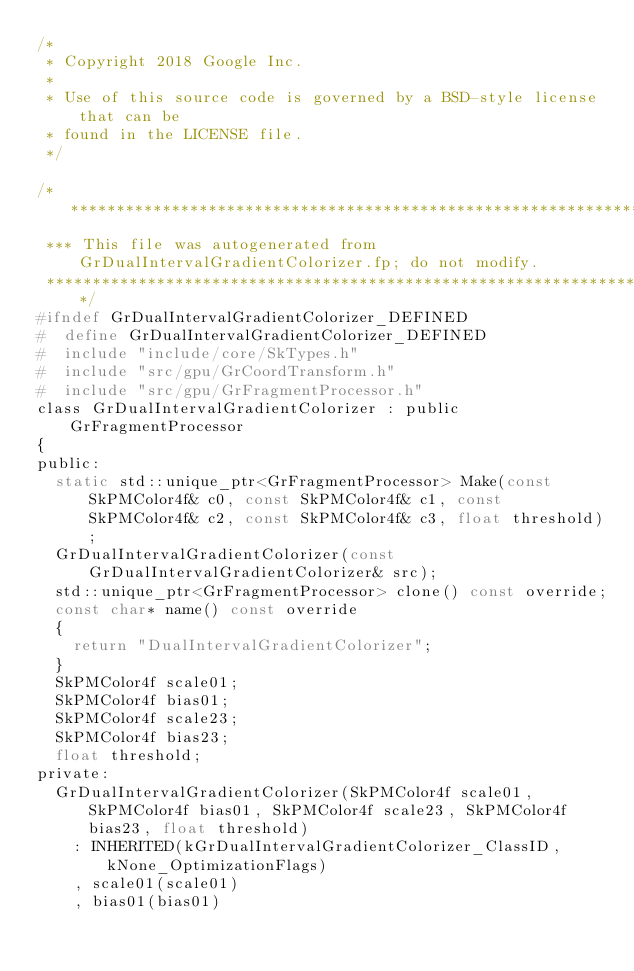<code> <loc_0><loc_0><loc_500><loc_500><_C_>/*
 * Copyright 2018 Google Inc.
 *
 * Use of this source code is governed by a BSD-style license that can be
 * found in the LICENSE file.
 */

/**************************************************************************************************
 *** This file was autogenerated from GrDualIntervalGradientColorizer.fp; do not modify.
 **************************************************************************************************/
#ifndef GrDualIntervalGradientColorizer_DEFINED
#  define GrDualIntervalGradientColorizer_DEFINED
#  include "include/core/SkTypes.h"
#  include "src/gpu/GrCoordTransform.h"
#  include "src/gpu/GrFragmentProcessor.h"
class GrDualIntervalGradientColorizer : public GrFragmentProcessor
{
public:
  static std::unique_ptr<GrFragmentProcessor> Make(const SkPMColor4f& c0, const SkPMColor4f& c1, const SkPMColor4f& c2, const SkPMColor4f& c3, float threshold);
  GrDualIntervalGradientColorizer(const GrDualIntervalGradientColorizer& src);
  std::unique_ptr<GrFragmentProcessor> clone() const override;
  const char* name() const override
  {
    return "DualIntervalGradientColorizer";
  }
  SkPMColor4f scale01;
  SkPMColor4f bias01;
  SkPMColor4f scale23;
  SkPMColor4f bias23;
  float threshold;
private:
  GrDualIntervalGradientColorizer(SkPMColor4f scale01, SkPMColor4f bias01, SkPMColor4f scale23, SkPMColor4f bias23, float threshold)
    : INHERITED(kGrDualIntervalGradientColorizer_ClassID, kNone_OptimizationFlags)
    , scale01(scale01)
    , bias01(bias01)</code> 